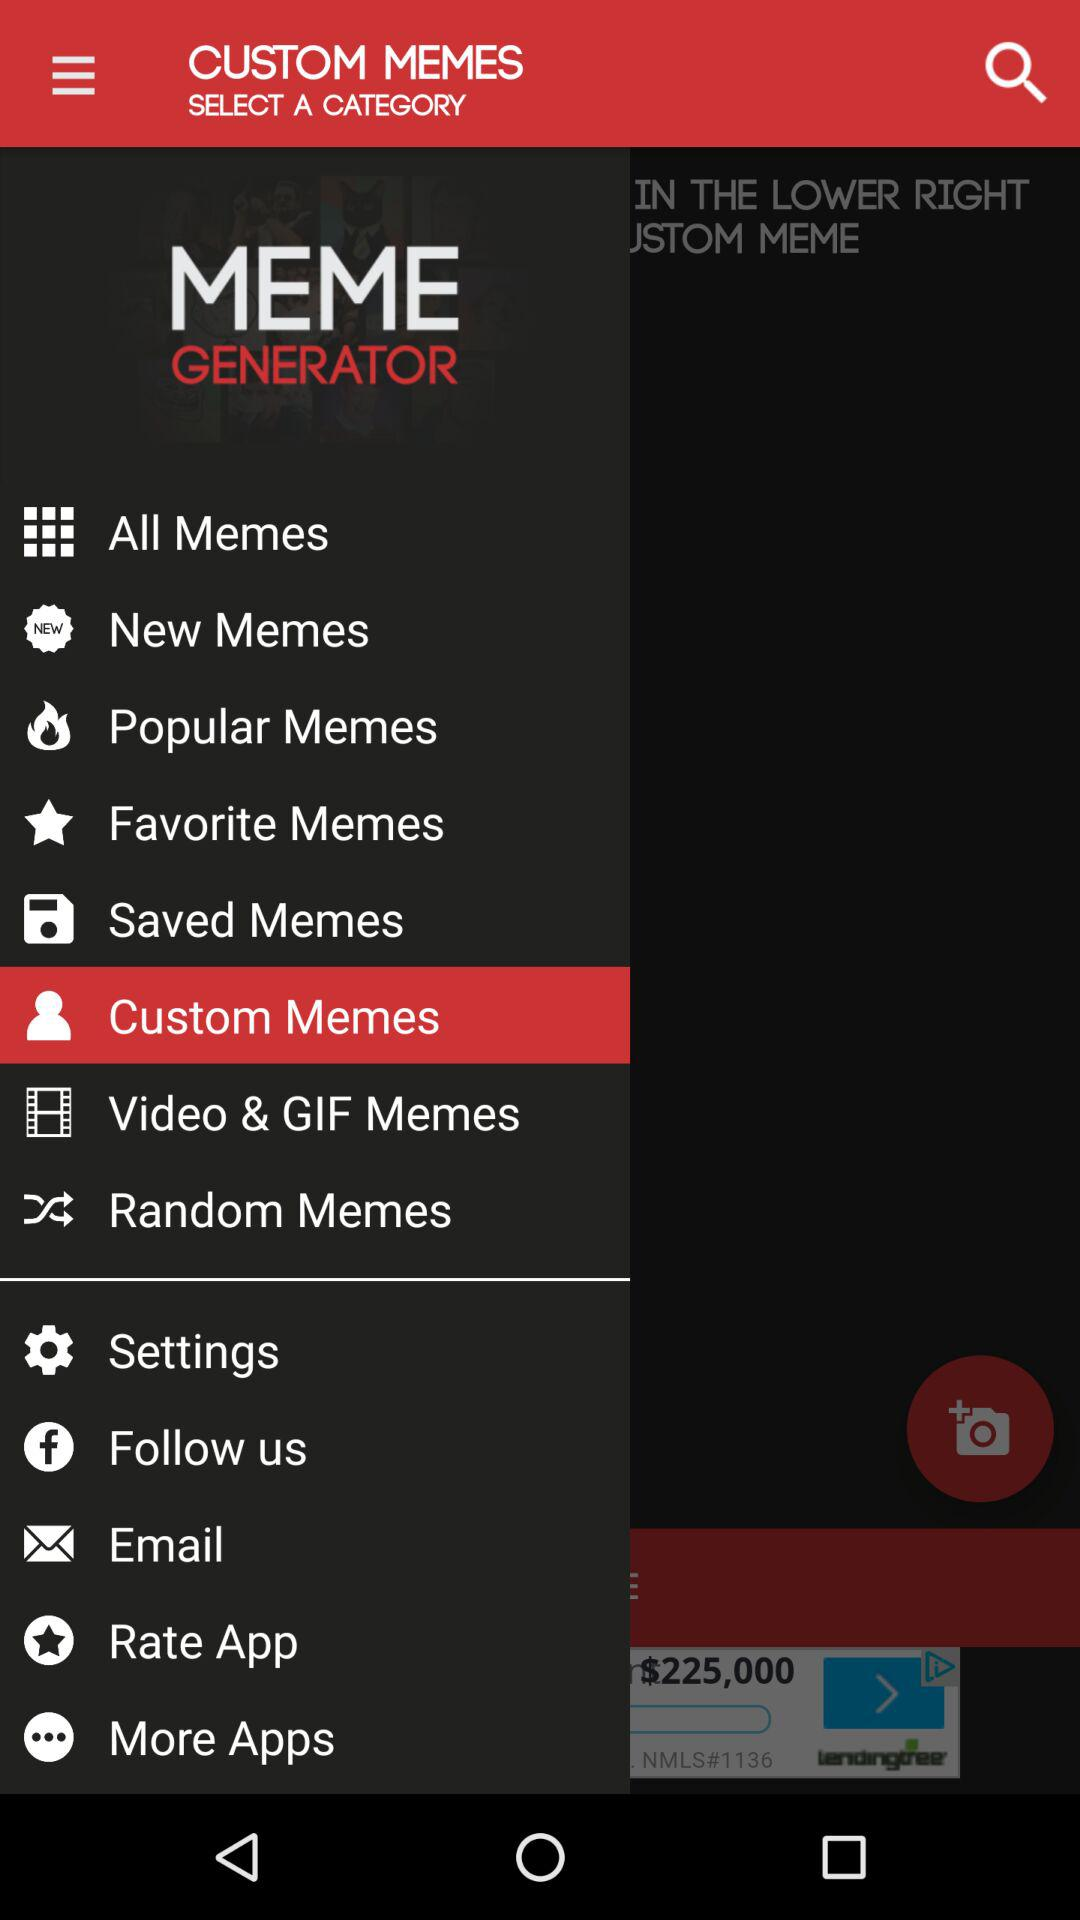What option has been selected? The selected option is "Custom Memes". 